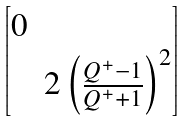Convert formula to latex. <formula><loc_0><loc_0><loc_500><loc_500>\begin{bmatrix} 0 & \\ & 2 \left ( \frac { Q ^ { + } - 1 } { Q ^ { + } + 1 } \right ) ^ { 2 } \end{bmatrix}</formula> 